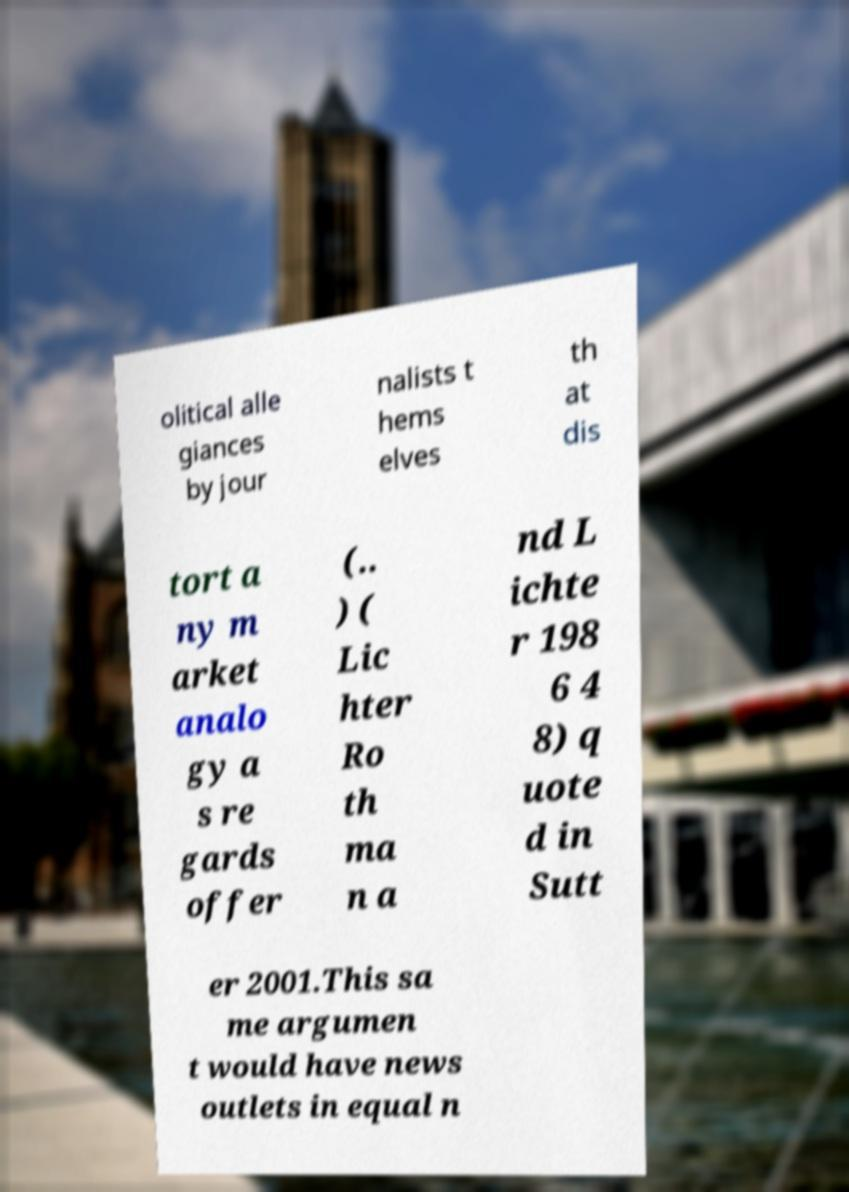Could you extract and type out the text from this image? olitical alle giances by jour nalists t hems elves th at dis tort a ny m arket analo gy a s re gards offer (.. ) ( Lic hter Ro th ma n a nd L ichte r 198 6 4 8) q uote d in Sutt er 2001.This sa me argumen t would have news outlets in equal n 